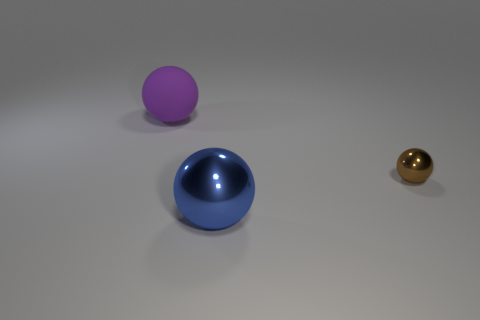What can you infer about the material of the objects? The objects appear to be made of different materials. The blue ball has a clear, reflective surface that suggests a hard, possibly glass-like material. The purple ball has a less reflective, matte finish indicating a softer or less polished material. Lastly, the brown ball's gleaming surface implies a metallic composition. 